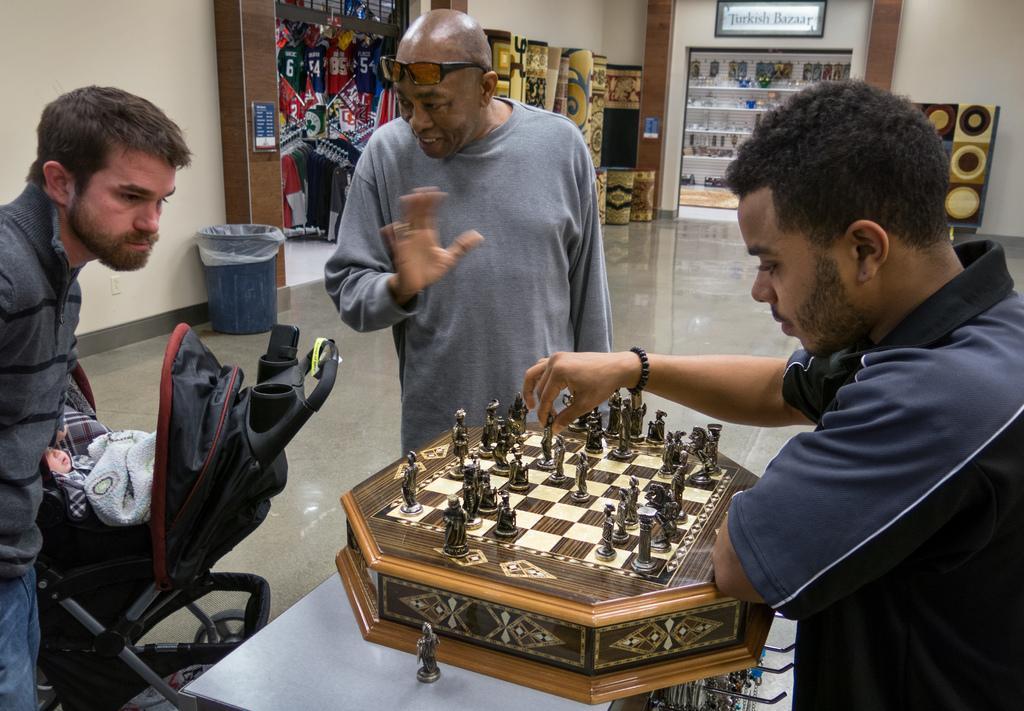Could you give a brief overview of what you see in this image? This is a picture in side of a building and there are the three persons stand middle of the image and there are playing a chess ,and right side person playing a chess and in front of him there is a person stand wearing a spectacles on his head , his mouth is open an d back side of him there is a dustbin. 